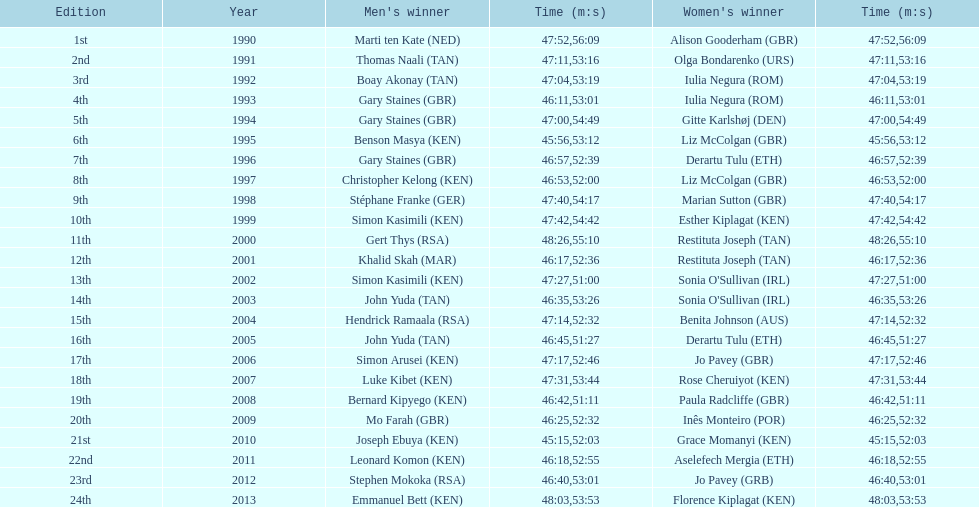How many men winners had times at least 46 minutes or under? 2. 